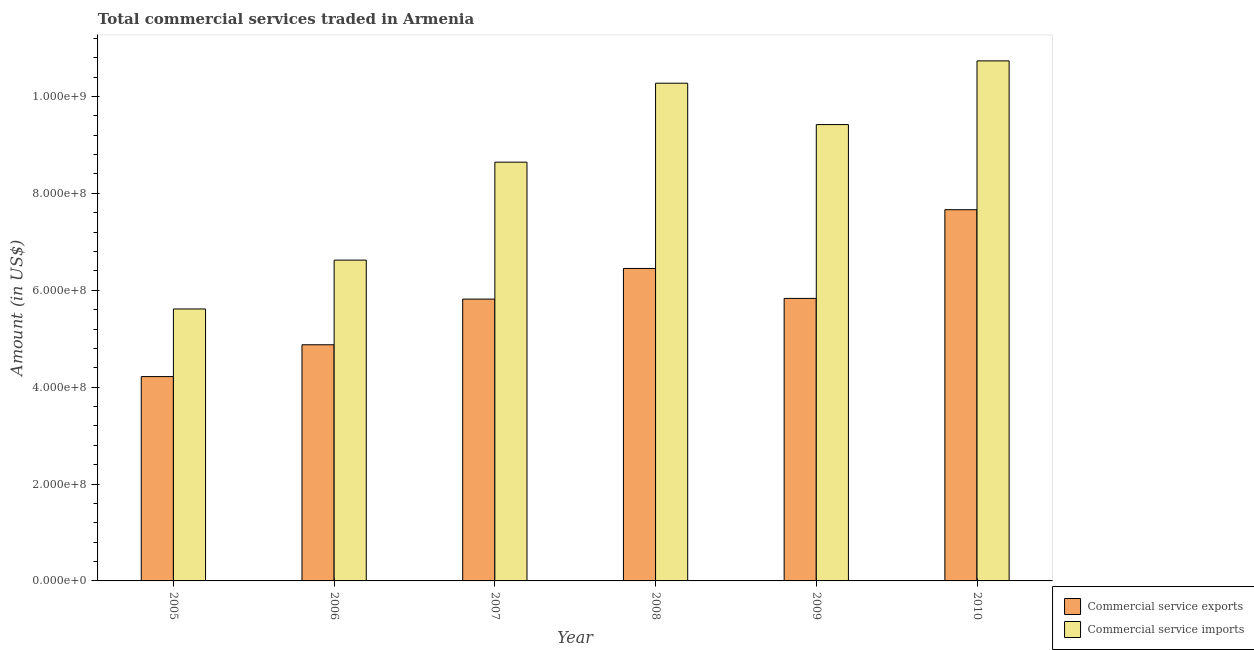Are the number of bars on each tick of the X-axis equal?
Give a very brief answer. Yes. How many bars are there on the 1st tick from the right?
Offer a very short reply. 2. What is the amount of commercial service imports in 2008?
Ensure brevity in your answer.  1.03e+09. Across all years, what is the maximum amount of commercial service exports?
Your answer should be compact. 7.66e+08. Across all years, what is the minimum amount of commercial service imports?
Provide a short and direct response. 5.61e+08. What is the total amount of commercial service exports in the graph?
Ensure brevity in your answer.  3.49e+09. What is the difference between the amount of commercial service imports in 2007 and that in 2009?
Your answer should be very brief. -7.76e+07. What is the difference between the amount of commercial service imports in 2008 and the amount of commercial service exports in 2007?
Keep it short and to the point. 1.63e+08. What is the average amount of commercial service imports per year?
Your answer should be compact. 8.55e+08. In the year 2005, what is the difference between the amount of commercial service imports and amount of commercial service exports?
Offer a terse response. 0. In how many years, is the amount of commercial service imports greater than 840000000 US$?
Provide a short and direct response. 4. What is the ratio of the amount of commercial service exports in 2007 to that in 2010?
Keep it short and to the point. 0.76. What is the difference between the highest and the second highest amount of commercial service imports?
Provide a succinct answer. 4.61e+07. What is the difference between the highest and the lowest amount of commercial service imports?
Keep it short and to the point. 5.12e+08. Is the sum of the amount of commercial service imports in 2005 and 2008 greater than the maximum amount of commercial service exports across all years?
Provide a succinct answer. Yes. What does the 1st bar from the left in 2006 represents?
Ensure brevity in your answer.  Commercial service exports. What does the 1st bar from the right in 2008 represents?
Make the answer very short. Commercial service imports. How many bars are there?
Make the answer very short. 12. Are all the bars in the graph horizontal?
Your response must be concise. No. How many years are there in the graph?
Provide a short and direct response. 6. Does the graph contain grids?
Your answer should be compact. No. How are the legend labels stacked?
Ensure brevity in your answer.  Vertical. What is the title of the graph?
Provide a short and direct response. Total commercial services traded in Armenia. Does "Investment" appear as one of the legend labels in the graph?
Offer a terse response. No. What is the label or title of the Y-axis?
Your response must be concise. Amount (in US$). What is the Amount (in US$) of Commercial service exports in 2005?
Keep it short and to the point. 4.22e+08. What is the Amount (in US$) of Commercial service imports in 2005?
Offer a terse response. 5.61e+08. What is the Amount (in US$) of Commercial service exports in 2006?
Provide a succinct answer. 4.87e+08. What is the Amount (in US$) in Commercial service imports in 2006?
Provide a short and direct response. 6.62e+08. What is the Amount (in US$) in Commercial service exports in 2007?
Keep it short and to the point. 5.82e+08. What is the Amount (in US$) of Commercial service imports in 2007?
Give a very brief answer. 8.64e+08. What is the Amount (in US$) of Commercial service exports in 2008?
Your answer should be very brief. 6.45e+08. What is the Amount (in US$) in Commercial service imports in 2008?
Provide a succinct answer. 1.03e+09. What is the Amount (in US$) in Commercial service exports in 2009?
Offer a terse response. 5.83e+08. What is the Amount (in US$) in Commercial service imports in 2009?
Make the answer very short. 9.42e+08. What is the Amount (in US$) of Commercial service exports in 2010?
Make the answer very short. 7.66e+08. What is the Amount (in US$) of Commercial service imports in 2010?
Your answer should be very brief. 1.07e+09. Across all years, what is the maximum Amount (in US$) in Commercial service exports?
Your response must be concise. 7.66e+08. Across all years, what is the maximum Amount (in US$) of Commercial service imports?
Ensure brevity in your answer.  1.07e+09. Across all years, what is the minimum Amount (in US$) in Commercial service exports?
Your answer should be very brief. 4.22e+08. Across all years, what is the minimum Amount (in US$) of Commercial service imports?
Offer a terse response. 5.61e+08. What is the total Amount (in US$) in Commercial service exports in the graph?
Provide a short and direct response. 3.49e+09. What is the total Amount (in US$) of Commercial service imports in the graph?
Provide a succinct answer. 5.13e+09. What is the difference between the Amount (in US$) of Commercial service exports in 2005 and that in 2006?
Provide a succinct answer. -6.57e+07. What is the difference between the Amount (in US$) of Commercial service imports in 2005 and that in 2006?
Ensure brevity in your answer.  -1.01e+08. What is the difference between the Amount (in US$) in Commercial service exports in 2005 and that in 2007?
Your response must be concise. -1.60e+08. What is the difference between the Amount (in US$) of Commercial service imports in 2005 and that in 2007?
Provide a succinct answer. -3.03e+08. What is the difference between the Amount (in US$) of Commercial service exports in 2005 and that in 2008?
Your answer should be compact. -2.23e+08. What is the difference between the Amount (in US$) of Commercial service imports in 2005 and that in 2008?
Your answer should be compact. -4.66e+08. What is the difference between the Amount (in US$) in Commercial service exports in 2005 and that in 2009?
Your response must be concise. -1.61e+08. What is the difference between the Amount (in US$) of Commercial service imports in 2005 and that in 2009?
Provide a short and direct response. -3.81e+08. What is the difference between the Amount (in US$) of Commercial service exports in 2005 and that in 2010?
Your response must be concise. -3.45e+08. What is the difference between the Amount (in US$) of Commercial service imports in 2005 and that in 2010?
Your answer should be very brief. -5.12e+08. What is the difference between the Amount (in US$) of Commercial service exports in 2006 and that in 2007?
Your answer should be compact. -9.43e+07. What is the difference between the Amount (in US$) in Commercial service imports in 2006 and that in 2007?
Keep it short and to the point. -2.02e+08. What is the difference between the Amount (in US$) in Commercial service exports in 2006 and that in 2008?
Ensure brevity in your answer.  -1.58e+08. What is the difference between the Amount (in US$) in Commercial service imports in 2006 and that in 2008?
Your answer should be very brief. -3.65e+08. What is the difference between the Amount (in US$) in Commercial service exports in 2006 and that in 2009?
Provide a succinct answer. -9.58e+07. What is the difference between the Amount (in US$) in Commercial service imports in 2006 and that in 2009?
Your answer should be compact. -2.80e+08. What is the difference between the Amount (in US$) of Commercial service exports in 2006 and that in 2010?
Make the answer very short. -2.79e+08. What is the difference between the Amount (in US$) in Commercial service imports in 2006 and that in 2010?
Your response must be concise. -4.11e+08. What is the difference between the Amount (in US$) in Commercial service exports in 2007 and that in 2008?
Give a very brief answer. -6.33e+07. What is the difference between the Amount (in US$) of Commercial service imports in 2007 and that in 2008?
Make the answer very short. -1.63e+08. What is the difference between the Amount (in US$) in Commercial service exports in 2007 and that in 2009?
Your answer should be compact. -1.47e+06. What is the difference between the Amount (in US$) of Commercial service imports in 2007 and that in 2009?
Your response must be concise. -7.76e+07. What is the difference between the Amount (in US$) of Commercial service exports in 2007 and that in 2010?
Your response must be concise. -1.85e+08. What is the difference between the Amount (in US$) of Commercial service imports in 2007 and that in 2010?
Offer a terse response. -2.09e+08. What is the difference between the Amount (in US$) of Commercial service exports in 2008 and that in 2009?
Offer a terse response. 6.18e+07. What is the difference between the Amount (in US$) in Commercial service imports in 2008 and that in 2009?
Offer a terse response. 8.54e+07. What is the difference between the Amount (in US$) of Commercial service exports in 2008 and that in 2010?
Keep it short and to the point. -1.21e+08. What is the difference between the Amount (in US$) in Commercial service imports in 2008 and that in 2010?
Offer a very short reply. -4.61e+07. What is the difference between the Amount (in US$) in Commercial service exports in 2009 and that in 2010?
Ensure brevity in your answer.  -1.83e+08. What is the difference between the Amount (in US$) of Commercial service imports in 2009 and that in 2010?
Offer a very short reply. -1.31e+08. What is the difference between the Amount (in US$) of Commercial service exports in 2005 and the Amount (in US$) of Commercial service imports in 2006?
Ensure brevity in your answer.  -2.40e+08. What is the difference between the Amount (in US$) in Commercial service exports in 2005 and the Amount (in US$) in Commercial service imports in 2007?
Provide a succinct answer. -4.43e+08. What is the difference between the Amount (in US$) of Commercial service exports in 2005 and the Amount (in US$) of Commercial service imports in 2008?
Keep it short and to the point. -6.06e+08. What is the difference between the Amount (in US$) of Commercial service exports in 2005 and the Amount (in US$) of Commercial service imports in 2009?
Give a very brief answer. -5.20e+08. What is the difference between the Amount (in US$) of Commercial service exports in 2005 and the Amount (in US$) of Commercial service imports in 2010?
Offer a very short reply. -6.52e+08. What is the difference between the Amount (in US$) of Commercial service exports in 2006 and the Amount (in US$) of Commercial service imports in 2007?
Your answer should be compact. -3.77e+08. What is the difference between the Amount (in US$) of Commercial service exports in 2006 and the Amount (in US$) of Commercial service imports in 2008?
Make the answer very short. -5.40e+08. What is the difference between the Amount (in US$) in Commercial service exports in 2006 and the Amount (in US$) in Commercial service imports in 2009?
Keep it short and to the point. -4.55e+08. What is the difference between the Amount (in US$) in Commercial service exports in 2006 and the Amount (in US$) in Commercial service imports in 2010?
Ensure brevity in your answer.  -5.86e+08. What is the difference between the Amount (in US$) in Commercial service exports in 2007 and the Amount (in US$) in Commercial service imports in 2008?
Your answer should be very brief. -4.46e+08. What is the difference between the Amount (in US$) in Commercial service exports in 2007 and the Amount (in US$) in Commercial service imports in 2009?
Your answer should be compact. -3.60e+08. What is the difference between the Amount (in US$) in Commercial service exports in 2007 and the Amount (in US$) in Commercial service imports in 2010?
Make the answer very short. -4.92e+08. What is the difference between the Amount (in US$) of Commercial service exports in 2008 and the Amount (in US$) of Commercial service imports in 2009?
Ensure brevity in your answer.  -2.97e+08. What is the difference between the Amount (in US$) in Commercial service exports in 2008 and the Amount (in US$) in Commercial service imports in 2010?
Your answer should be compact. -4.28e+08. What is the difference between the Amount (in US$) in Commercial service exports in 2009 and the Amount (in US$) in Commercial service imports in 2010?
Offer a terse response. -4.90e+08. What is the average Amount (in US$) in Commercial service exports per year?
Offer a terse response. 5.81e+08. What is the average Amount (in US$) of Commercial service imports per year?
Your answer should be compact. 8.55e+08. In the year 2005, what is the difference between the Amount (in US$) of Commercial service exports and Amount (in US$) of Commercial service imports?
Offer a terse response. -1.40e+08. In the year 2006, what is the difference between the Amount (in US$) in Commercial service exports and Amount (in US$) in Commercial service imports?
Your answer should be compact. -1.75e+08. In the year 2007, what is the difference between the Amount (in US$) of Commercial service exports and Amount (in US$) of Commercial service imports?
Your answer should be very brief. -2.83e+08. In the year 2008, what is the difference between the Amount (in US$) of Commercial service exports and Amount (in US$) of Commercial service imports?
Provide a short and direct response. -3.82e+08. In the year 2009, what is the difference between the Amount (in US$) in Commercial service exports and Amount (in US$) in Commercial service imports?
Keep it short and to the point. -3.59e+08. In the year 2010, what is the difference between the Amount (in US$) of Commercial service exports and Amount (in US$) of Commercial service imports?
Your answer should be very brief. -3.07e+08. What is the ratio of the Amount (in US$) of Commercial service exports in 2005 to that in 2006?
Offer a terse response. 0.87. What is the ratio of the Amount (in US$) of Commercial service imports in 2005 to that in 2006?
Your answer should be very brief. 0.85. What is the ratio of the Amount (in US$) of Commercial service exports in 2005 to that in 2007?
Offer a very short reply. 0.73. What is the ratio of the Amount (in US$) of Commercial service imports in 2005 to that in 2007?
Provide a short and direct response. 0.65. What is the ratio of the Amount (in US$) in Commercial service exports in 2005 to that in 2008?
Provide a succinct answer. 0.65. What is the ratio of the Amount (in US$) of Commercial service imports in 2005 to that in 2008?
Your answer should be compact. 0.55. What is the ratio of the Amount (in US$) of Commercial service exports in 2005 to that in 2009?
Offer a very short reply. 0.72. What is the ratio of the Amount (in US$) in Commercial service imports in 2005 to that in 2009?
Offer a terse response. 0.6. What is the ratio of the Amount (in US$) in Commercial service exports in 2005 to that in 2010?
Ensure brevity in your answer.  0.55. What is the ratio of the Amount (in US$) of Commercial service imports in 2005 to that in 2010?
Offer a very short reply. 0.52. What is the ratio of the Amount (in US$) in Commercial service exports in 2006 to that in 2007?
Offer a terse response. 0.84. What is the ratio of the Amount (in US$) of Commercial service imports in 2006 to that in 2007?
Your answer should be very brief. 0.77. What is the ratio of the Amount (in US$) of Commercial service exports in 2006 to that in 2008?
Keep it short and to the point. 0.76. What is the ratio of the Amount (in US$) in Commercial service imports in 2006 to that in 2008?
Offer a very short reply. 0.64. What is the ratio of the Amount (in US$) of Commercial service exports in 2006 to that in 2009?
Ensure brevity in your answer.  0.84. What is the ratio of the Amount (in US$) of Commercial service imports in 2006 to that in 2009?
Offer a terse response. 0.7. What is the ratio of the Amount (in US$) of Commercial service exports in 2006 to that in 2010?
Provide a short and direct response. 0.64. What is the ratio of the Amount (in US$) of Commercial service imports in 2006 to that in 2010?
Your answer should be compact. 0.62. What is the ratio of the Amount (in US$) in Commercial service exports in 2007 to that in 2008?
Provide a succinct answer. 0.9. What is the ratio of the Amount (in US$) of Commercial service imports in 2007 to that in 2008?
Offer a very short reply. 0.84. What is the ratio of the Amount (in US$) in Commercial service exports in 2007 to that in 2009?
Make the answer very short. 1. What is the ratio of the Amount (in US$) in Commercial service imports in 2007 to that in 2009?
Your answer should be very brief. 0.92. What is the ratio of the Amount (in US$) in Commercial service exports in 2007 to that in 2010?
Your answer should be compact. 0.76. What is the ratio of the Amount (in US$) of Commercial service imports in 2007 to that in 2010?
Give a very brief answer. 0.81. What is the ratio of the Amount (in US$) in Commercial service exports in 2008 to that in 2009?
Offer a very short reply. 1.11. What is the ratio of the Amount (in US$) of Commercial service imports in 2008 to that in 2009?
Provide a short and direct response. 1.09. What is the ratio of the Amount (in US$) in Commercial service exports in 2008 to that in 2010?
Your answer should be compact. 0.84. What is the ratio of the Amount (in US$) in Commercial service imports in 2008 to that in 2010?
Provide a short and direct response. 0.96. What is the ratio of the Amount (in US$) in Commercial service exports in 2009 to that in 2010?
Give a very brief answer. 0.76. What is the ratio of the Amount (in US$) of Commercial service imports in 2009 to that in 2010?
Make the answer very short. 0.88. What is the difference between the highest and the second highest Amount (in US$) in Commercial service exports?
Keep it short and to the point. 1.21e+08. What is the difference between the highest and the second highest Amount (in US$) of Commercial service imports?
Provide a short and direct response. 4.61e+07. What is the difference between the highest and the lowest Amount (in US$) of Commercial service exports?
Make the answer very short. 3.45e+08. What is the difference between the highest and the lowest Amount (in US$) of Commercial service imports?
Your answer should be compact. 5.12e+08. 